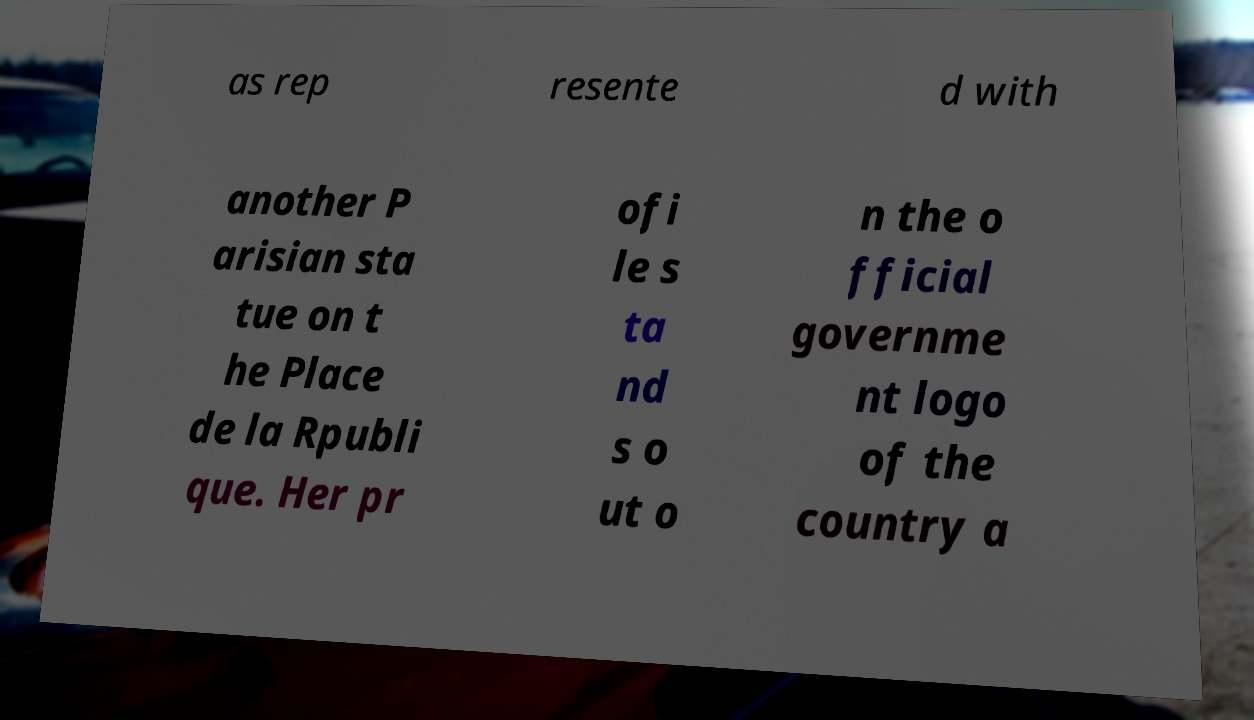Please read and relay the text visible in this image. What does it say? as rep resente d with another P arisian sta tue on t he Place de la Rpubli que. Her pr ofi le s ta nd s o ut o n the o fficial governme nt logo of the country a 